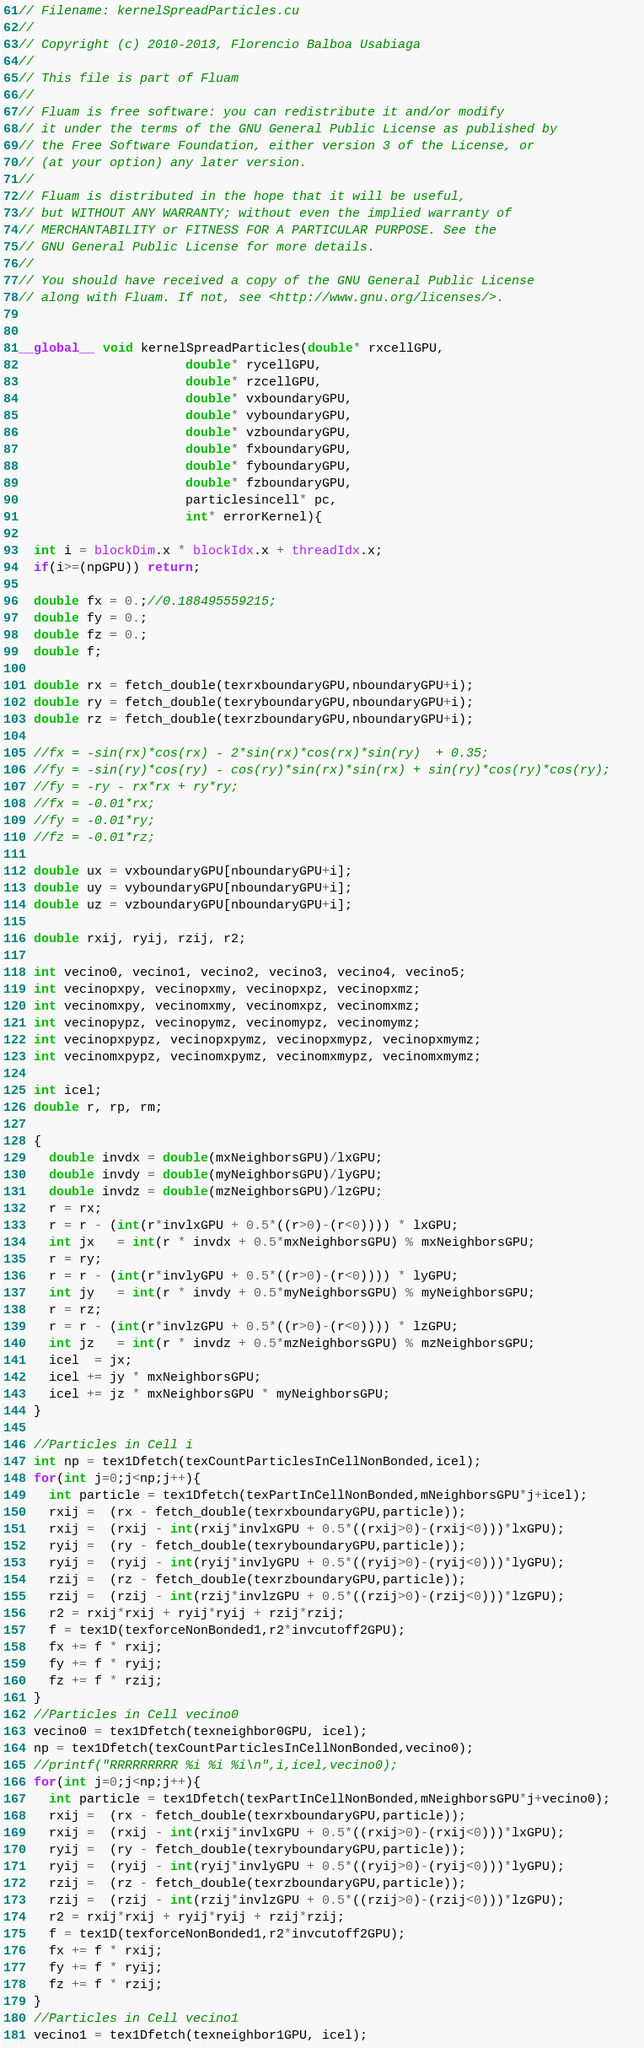Convert code to text. <code><loc_0><loc_0><loc_500><loc_500><_Cuda_>// Filename: kernelSpreadParticles.cu
//
// Copyright (c) 2010-2013, Florencio Balboa Usabiaga
//
// This file is part of Fluam
//
// Fluam is free software: you can redistribute it and/or modify
// it under the terms of the GNU General Public License as published by
// the Free Software Foundation, either version 3 of the License, or
// (at your option) any later version.
//
// Fluam is distributed in the hope that it will be useful,
// but WITHOUT ANY WARRANTY; without even the implied warranty of
// MERCHANTABILITY or FITNESS FOR A PARTICULAR PURPOSE. See the
// GNU General Public License for more details.
//
// You should have received a copy of the GNU General Public License
// along with Fluam. If not, see <http://www.gnu.org/licenses/>.


__global__ void kernelSpreadParticles(double* rxcellGPU, 
				      double* rycellGPU, 
				      double* rzcellGPU,
				      double* vxboundaryGPU,
				      double* vyboundaryGPU,
				      double* vzboundaryGPU,
				      double* fxboundaryGPU, 
				      double* fyboundaryGPU, 
				      double* fzboundaryGPU,
				      particlesincell* pc, 
				      int* errorKernel){
  
  int i = blockDim.x * blockIdx.x + threadIdx.x;
  if(i>=(npGPU)) return;   
  
  double fx = 0.;//0.188495559215;
  double fy = 0.;
  double fz = 0.;
  double f;
 
  double rx = fetch_double(texrxboundaryGPU,nboundaryGPU+i);
  double ry = fetch_double(texryboundaryGPU,nboundaryGPU+i);
  double rz = fetch_double(texrzboundaryGPU,nboundaryGPU+i);
  
  //fx = -sin(rx)*cos(rx) - 2*sin(rx)*cos(rx)*sin(ry)  + 0.35;
  //fy = -sin(ry)*cos(ry) - cos(ry)*sin(rx)*sin(rx) + sin(ry)*cos(ry)*cos(ry);
  //fy = -ry - rx*rx + ry*ry;
  //fx = -0.01*rx;
  //fy = -0.01*ry;
  //fz = -0.01*rz;

  double ux = vxboundaryGPU[nboundaryGPU+i];
  double uy = vyboundaryGPU[nboundaryGPU+i];
  double uz = vzboundaryGPU[nboundaryGPU+i];
  
  double rxij, ryij, rzij, r2;

  int vecino0, vecino1, vecino2, vecino3, vecino4, vecino5;
  int vecinopxpy, vecinopxmy, vecinopxpz, vecinopxmz;
  int vecinomxpy, vecinomxmy, vecinomxpz, vecinomxmz;
  int vecinopypz, vecinopymz, vecinomypz, vecinomymz;
  int vecinopxpypz, vecinopxpymz, vecinopxmypz, vecinopxmymz;
  int vecinomxpypz, vecinomxpymz, vecinomxmypz, vecinomxmymz;
  
  int icel;
  double r, rp, rm;

  {
    double invdx = double(mxNeighborsGPU)/lxGPU;
    double invdy = double(myNeighborsGPU)/lyGPU;
    double invdz = double(mzNeighborsGPU)/lzGPU;
    r = rx;
    r = r - (int(r*invlxGPU + 0.5*((r>0)-(r<0)))) * lxGPU;
    int jx   = int(r * invdx + 0.5*mxNeighborsGPU) % mxNeighborsGPU;
    r = ry;
    r = r - (int(r*invlyGPU + 0.5*((r>0)-(r<0)))) * lyGPU;
    int jy   = int(r * invdy + 0.5*myNeighborsGPU) % myNeighborsGPU;
    r = rz;
    r = r - (int(r*invlzGPU + 0.5*((r>0)-(r<0)))) * lzGPU;
    int jz   = int(r * invdz + 0.5*mzNeighborsGPU) % mzNeighborsGPU;
    icel  = jx;
    icel += jy * mxNeighborsGPU;
    icel += jz * mxNeighborsGPU * myNeighborsGPU;    
  }
  
  //Particles in Cell i
  int np = tex1Dfetch(texCountParticlesInCellNonBonded,icel);
  for(int j=0;j<np;j++){
    int particle = tex1Dfetch(texPartInCellNonBonded,mNeighborsGPU*j+icel);
    rxij =  (rx - fetch_double(texrxboundaryGPU,particle));
    rxij =  (rxij - int(rxij*invlxGPU + 0.5*((rxij>0)-(rxij<0)))*lxGPU);
    ryij =  (ry - fetch_double(texryboundaryGPU,particle));
    ryij =  (ryij - int(ryij*invlyGPU + 0.5*((ryij>0)-(ryij<0)))*lyGPU);
    rzij =  (rz - fetch_double(texrzboundaryGPU,particle));
    rzij =  (rzij - int(rzij*invlzGPU + 0.5*((rzij>0)-(rzij<0)))*lzGPU);
    r2 = rxij*rxij + ryij*ryij + rzij*rzij;
    f = tex1D(texforceNonBonded1,r2*invcutoff2GPU);
    fx += f * rxij;
    fy += f * ryij;
    fz += f * rzij;
  }  
  //Particles in Cell vecino0
  vecino0 = tex1Dfetch(texneighbor0GPU, icel);
  np = tex1Dfetch(texCountParticlesInCellNonBonded,vecino0);
  //printf("RRRRRRRRR %i %i %i\n",i,icel,vecino0);
  for(int j=0;j<np;j++){
    int particle = tex1Dfetch(texPartInCellNonBonded,mNeighborsGPU*j+vecino0);    
    rxij =  (rx - fetch_double(texrxboundaryGPU,particle));
    rxij =  (rxij - int(rxij*invlxGPU + 0.5*((rxij>0)-(rxij<0)))*lxGPU);
    ryij =  (ry - fetch_double(texryboundaryGPU,particle));
    ryij =  (ryij - int(ryij*invlyGPU + 0.5*((ryij>0)-(ryij<0)))*lyGPU);
    rzij =  (rz - fetch_double(texrzboundaryGPU,particle));
    rzij =  (rzij - int(rzij*invlzGPU + 0.5*((rzij>0)-(rzij<0)))*lzGPU);
    r2 = rxij*rxij + ryij*ryij + rzij*rzij;
    f = tex1D(texforceNonBonded1,r2*invcutoff2GPU);
    fx += f * rxij;
    fy += f * ryij;
    fz += f * rzij;
  }
  //Particles in Cell vecino1
  vecino1 = tex1Dfetch(texneighbor1GPU, icel);</code> 